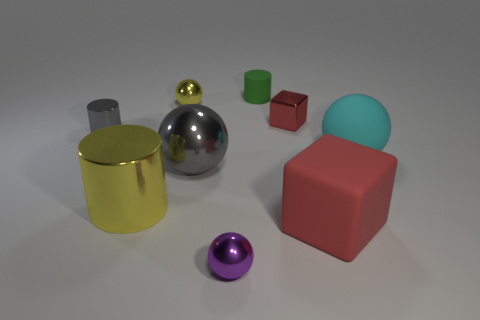Subtract 1 balls. How many balls are left? 3 Subtract all spheres. How many objects are left? 5 Subtract all red things. Subtract all big purple metal cylinders. How many objects are left? 7 Add 7 small green things. How many small green things are left? 8 Add 7 big gray rubber things. How many big gray rubber things exist? 7 Subtract 0 cyan cubes. How many objects are left? 9 